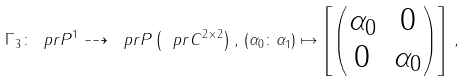Convert formula to latex. <formula><loc_0><loc_0><loc_500><loc_500>\Gamma _ { 3 } \colon \ p r P ^ { 1 } \dashrightarrow \ p r P \left ( \ p r C ^ { 2 \times 2 } \right ) , \, ( \alpha _ { 0 } \colon \alpha _ { 1 } ) \mapsto \left [ \begin{pmatrix} \alpha _ { 0 } & 0 \\ 0 & \alpha _ { 0 } \end{pmatrix} \right ] \, ,</formula> 